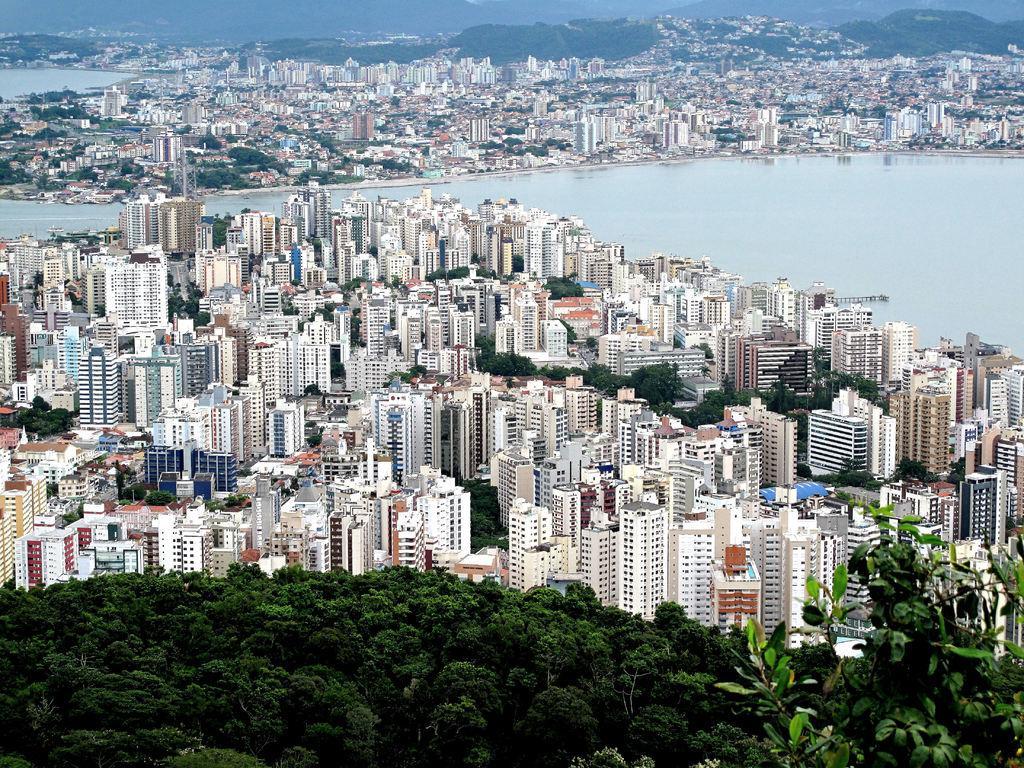Please provide a concise description of this image. In this picture there are trees at the bottom side of the image and there are skyscrapers and trees in the image, there is water in the image. 